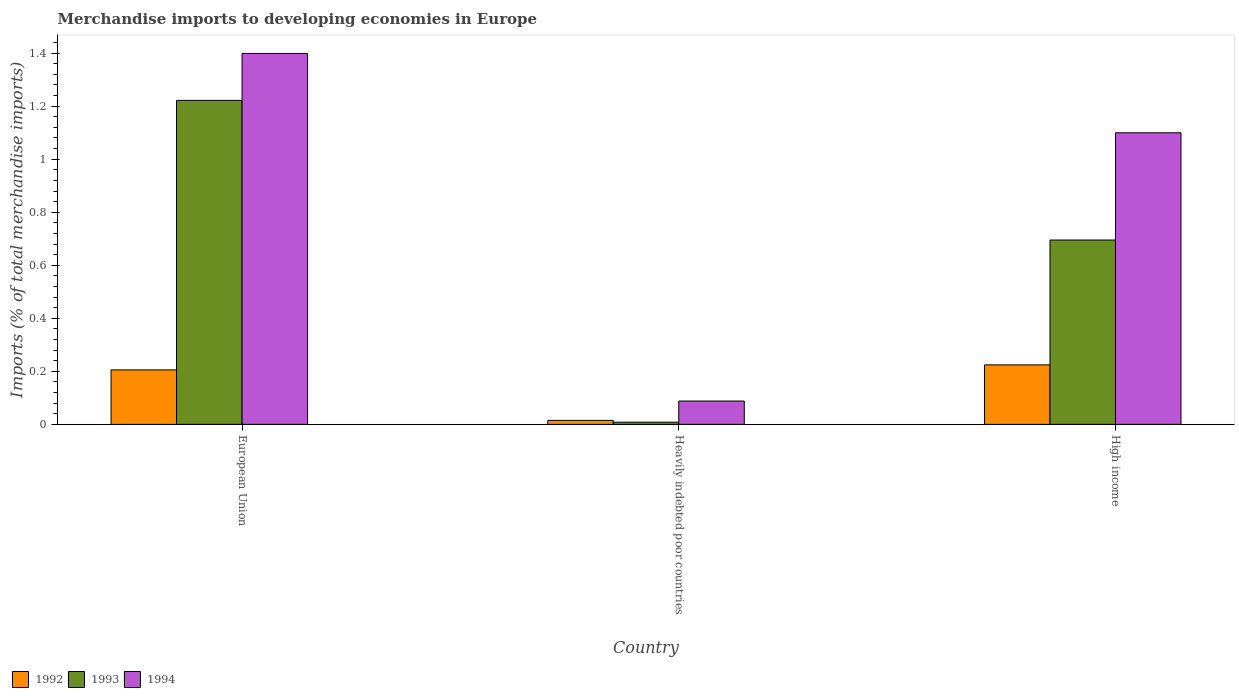Are the number of bars per tick equal to the number of legend labels?
Make the answer very short. Yes. Are the number of bars on each tick of the X-axis equal?
Keep it short and to the point. Yes. How many bars are there on the 2nd tick from the left?
Ensure brevity in your answer.  3. How many bars are there on the 2nd tick from the right?
Keep it short and to the point. 3. In how many cases, is the number of bars for a given country not equal to the number of legend labels?
Keep it short and to the point. 0. What is the percentage total merchandise imports in 1993 in European Union?
Make the answer very short. 1.22. Across all countries, what is the maximum percentage total merchandise imports in 1993?
Your answer should be very brief. 1.22. Across all countries, what is the minimum percentage total merchandise imports in 1993?
Offer a very short reply. 0.01. In which country was the percentage total merchandise imports in 1992 maximum?
Your answer should be compact. High income. In which country was the percentage total merchandise imports in 1993 minimum?
Provide a short and direct response. Heavily indebted poor countries. What is the total percentage total merchandise imports in 1993 in the graph?
Ensure brevity in your answer.  1.93. What is the difference between the percentage total merchandise imports in 1993 in European Union and that in High income?
Provide a succinct answer. 0.53. What is the difference between the percentage total merchandise imports in 1992 in European Union and the percentage total merchandise imports in 1993 in High income?
Make the answer very short. -0.49. What is the average percentage total merchandise imports in 1994 per country?
Offer a terse response. 0.86. What is the difference between the percentage total merchandise imports of/in 1993 and percentage total merchandise imports of/in 1994 in High income?
Offer a very short reply. -0.4. In how many countries, is the percentage total merchandise imports in 1992 greater than 0.24000000000000002 %?
Keep it short and to the point. 0. What is the ratio of the percentage total merchandise imports in 1994 in European Union to that in Heavily indebted poor countries?
Make the answer very short. 15.9. Is the percentage total merchandise imports in 1992 in Heavily indebted poor countries less than that in High income?
Give a very brief answer. Yes. Is the difference between the percentage total merchandise imports in 1993 in European Union and High income greater than the difference between the percentage total merchandise imports in 1994 in European Union and High income?
Offer a terse response. Yes. What is the difference between the highest and the second highest percentage total merchandise imports in 1994?
Provide a succinct answer. -1.31. What is the difference between the highest and the lowest percentage total merchandise imports in 1992?
Offer a very short reply. 0.21. What does the 2nd bar from the right in Heavily indebted poor countries represents?
Provide a succinct answer. 1993. How many bars are there?
Provide a succinct answer. 9. What is the difference between two consecutive major ticks on the Y-axis?
Ensure brevity in your answer.  0.2. How many legend labels are there?
Your answer should be compact. 3. What is the title of the graph?
Keep it short and to the point. Merchandise imports to developing economies in Europe. What is the label or title of the Y-axis?
Your answer should be compact. Imports (% of total merchandise imports). What is the Imports (% of total merchandise imports) in 1992 in European Union?
Make the answer very short. 0.21. What is the Imports (% of total merchandise imports) in 1993 in European Union?
Your answer should be compact. 1.22. What is the Imports (% of total merchandise imports) in 1994 in European Union?
Your answer should be very brief. 1.4. What is the Imports (% of total merchandise imports) of 1992 in Heavily indebted poor countries?
Offer a very short reply. 0.02. What is the Imports (% of total merchandise imports) in 1993 in Heavily indebted poor countries?
Offer a terse response. 0.01. What is the Imports (% of total merchandise imports) in 1994 in Heavily indebted poor countries?
Provide a succinct answer. 0.09. What is the Imports (% of total merchandise imports) in 1992 in High income?
Your answer should be very brief. 0.22. What is the Imports (% of total merchandise imports) of 1993 in High income?
Keep it short and to the point. 0.7. What is the Imports (% of total merchandise imports) in 1994 in High income?
Keep it short and to the point. 1.1. Across all countries, what is the maximum Imports (% of total merchandise imports) of 1992?
Provide a succinct answer. 0.22. Across all countries, what is the maximum Imports (% of total merchandise imports) in 1993?
Make the answer very short. 1.22. Across all countries, what is the maximum Imports (% of total merchandise imports) in 1994?
Provide a succinct answer. 1.4. Across all countries, what is the minimum Imports (% of total merchandise imports) in 1992?
Your answer should be very brief. 0.02. Across all countries, what is the minimum Imports (% of total merchandise imports) in 1993?
Keep it short and to the point. 0.01. Across all countries, what is the minimum Imports (% of total merchandise imports) in 1994?
Your answer should be compact. 0.09. What is the total Imports (% of total merchandise imports) in 1992 in the graph?
Keep it short and to the point. 0.44. What is the total Imports (% of total merchandise imports) of 1993 in the graph?
Your response must be concise. 1.93. What is the total Imports (% of total merchandise imports) of 1994 in the graph?
Your response must be concise. 2.59. What is the difference between the Imports (% of total merchandise imports) of 1992 in European Union and that in Heavily indebted poor countries?
Your response must be concise. 0.19. What is the difference between the Imports (% of total merchandise imports) of 1993 in European Union and that in Heavily indebted poor countries?
Provide a succinct answer. 1.21. What is the difference between the Imports (% of total merchandise imports) of 1994 in European Union and that in Heavily indebted poor countries?
Ensure brevity in your answer.  1.31. What is the difference between the Imports (% of total merchandise imports) of 1992 in European Union and that in High income?
Your answer should be very brief. -0.02. What is the difference between the Imports (% of total merchandise imports) of 1993 in European Union and that in High income?
Ensure brevity in your answer.  0.53. What is the difference between the Imports (% of total merchandise imports) of 1994 in European Union and that in High income?
Offer a terse response. 0.3. What is the difference between the Imports (% of total merchandise imports) in 1992 in Heavily indebted poor countries and that in High income?
Provide a succinct answer. -0.21. What is the difference between the Imports (% of total merchandise imports) of 1993 in Heavily indebted poor countries and that in High income?
Give a very brief answer. -0.69. What is the difference between the Imports (% of total merchandise imports) in 1994 in Heavily indebted poor countries and that in High income?
Your response must be concise. -1.01. What is the difference between the Imports (% of total merchandise imports) in 1992 in European Union and the Imports (% of total merchandise imports) in 1993 in Heavily indebted poor countries?
Give a very brief answer. 0.2. What is the difference between the Imports (% of total merchandise imports) of 1992 in European Union and the Imports (% of total merchandise imports) of 1994 in Heavily indebted poor countries?
Provide a succinct answer. 0.12. What is the difference between the Imports (% of total merchandise imports) of 1993 in European Union and the Imports (% of total merchandise imports) of 1994 in Heavily indebted poor countries?
Keep it short and to the point. 1.13. What is the difference between the Imports (% of total merchandise imports) of 1992 in European Union and the Imports (% of total merchandise imports) of 1993 in High income?
Your response must be concise. -0.49. What is the difference between the Imports (% of total merchandise imports) of 1992 in European Union and the Imports (% of total merchandise imports) of 1994 in High income?
Offer a terse response. -0.89. What is the difference between the Imports (% of total merchandise imports) in 1993 in European Union and the Imports (% of total merchandise imports) in 1994 in High income?
Offer a terse response. 0.12. What is the difference between the Imports (% of total merchandise imports) of 1992 in Heavily indebted poor countries and the Imports (% of total merchandise imports) of 1993 in High income?
Keep it short and to the point. -0.68. What is the difference between the Imports (% of total merchandise imports) of 1992 in Heavily indebted poor countries and the Imports (% of total merchandise imports) of 1994 in High income?
Ensure brevity in your answer.  -1.08. What is the difference between the Imports (% of total merchandise imports) of 1993 in Heavily indebted poor countries and the Imports (% of total merchandise imports) of 1994 in High income?
Ensure brevity in your answer.  -1.09. What is the average Imports (% of total merchandise imports) in 1992 per country?
Your answer should be very brief. 0.15. What is the average Imports (% of total merchandise imports) in 1993 per country?
Your response must be concise. 0.64. What is the average Imports (% of total merchandise imports) in 1994 per country?
Offer a terse response. 0.86. What is the difference between the Imports (% of total merchandise imports) of 1992 and Imports (% of total merchandise imports) of 1993 in European Union?
Make the answer very short. -1.02. What is the difference between the Imports (% of total merchandise imports) in 1992 and Imports (% of total merchandise imports) in 1994 in European Union?
Ensure brevity in your answer.  -1.19. What is the difference between the Imports (% of total merchandise imports) of 1993 and Imports (% of total merchandise imports) of 1994 in European Union?
Your response must be concise. -0.18. What is the difference between the Imports (% of total merchandise imports) of 1992 and Imports (% of total merchandise imports) of 1993 in Heavily indebted poor countries?
Your answer should be compact. 0.01. What is the difference between the Imports (% of total merchandise imports) in 1992 and Imports (% of total merchandise imports) in 1994 in Heavily indebted poor countries?
Your answer should be very brief. -0.07. What is the difference between the Imports (% of total merchandise imports) in 1993 and Imports (% of total merchandise imports) in 1994 in Heavily indebted poor countries?
Your response must be concise. -0.08. What is the difference between the Imports (% of total merchandise imports) in 1992 and Imports (% of total merchandise imports) in 1993 in High income?
Your response must be concise. -0.47. What is the difference between the Imports (% of total merchandise imports) in 1992 and Imports (% of total merchandise imports) in 1994 in High income?
Offer a terse response. -0.88. What is the difference between the Imports (% of total merchandise imports) in 1993 and Imports (% of total merchandise imports) in 1994 in High income?
Provide a short and direct response. -0.4. What is the ratio of the Imports (% of total merchandise imports) in 1992 in European Union to that in Heavily indebted poor countries?
Your answer should be compact. 13.61. What is the ratio of the Imports (% of total merchandise imports) in 1993 in European Union to that in Heavily indebted poor countries?
Your answer should be very brief. 147.67. What is the ratio of the Imports (% of total merchandise imports) in 1994 in European Union to that in Heavily indebted poor countries?
Offer a terse response. 15.9. What is the ratio of the Imports (% of total merchandise imports) in 1992 in European Union to that in High income?
Your response must be concise. 0.92. What is the ratio of the Imports (% of total merchandise imports) of 1993 in European Union to that in High income?
Your answer should be very brief. 1.76. What is the ratio of the Imports (% of total merchandise imports) of 1994 in European Union to that in High income?
Keep it short and to the point. 1.27. What is the ratio of the Imports (% of total merchandise imports) in 1992 in Heavily indebted poor countries to that in High income?
Offer a terse response. 0.07. What is the ratio of the Imports (% of total merchandise imports) in 1993 in Heavily indebted poor countries to that in High income?
Ensure brevity in your answer.  0.01. What is the difference between the highest and the second highest Imports (% of total merchandise imports) of 1992?
Offer a very short reply. 0.02. What is the difference between the highest and the second highest Imports (% of total merchandise imports) of 1993?
Keep it short and to the point. 0.53. What is the difference between the highest and the second highest Imports (% of total merchandise imports) in 1994?
Make the answer very short. 0.3. What is the difference between the highest and the lowest Imports (% of total merchandise imports) of 1992?
Ensure brevity in your answer.  0.21. What is the difference between the highest and the lowest Imports (% of total merchandise imports) of 1993?
Provide a succinct answer. 1.21. What is the difference between the highest and the lowest Imports (% of total merchandise imports) of 1994?
Ensure brevity in your answer.  1.31. 